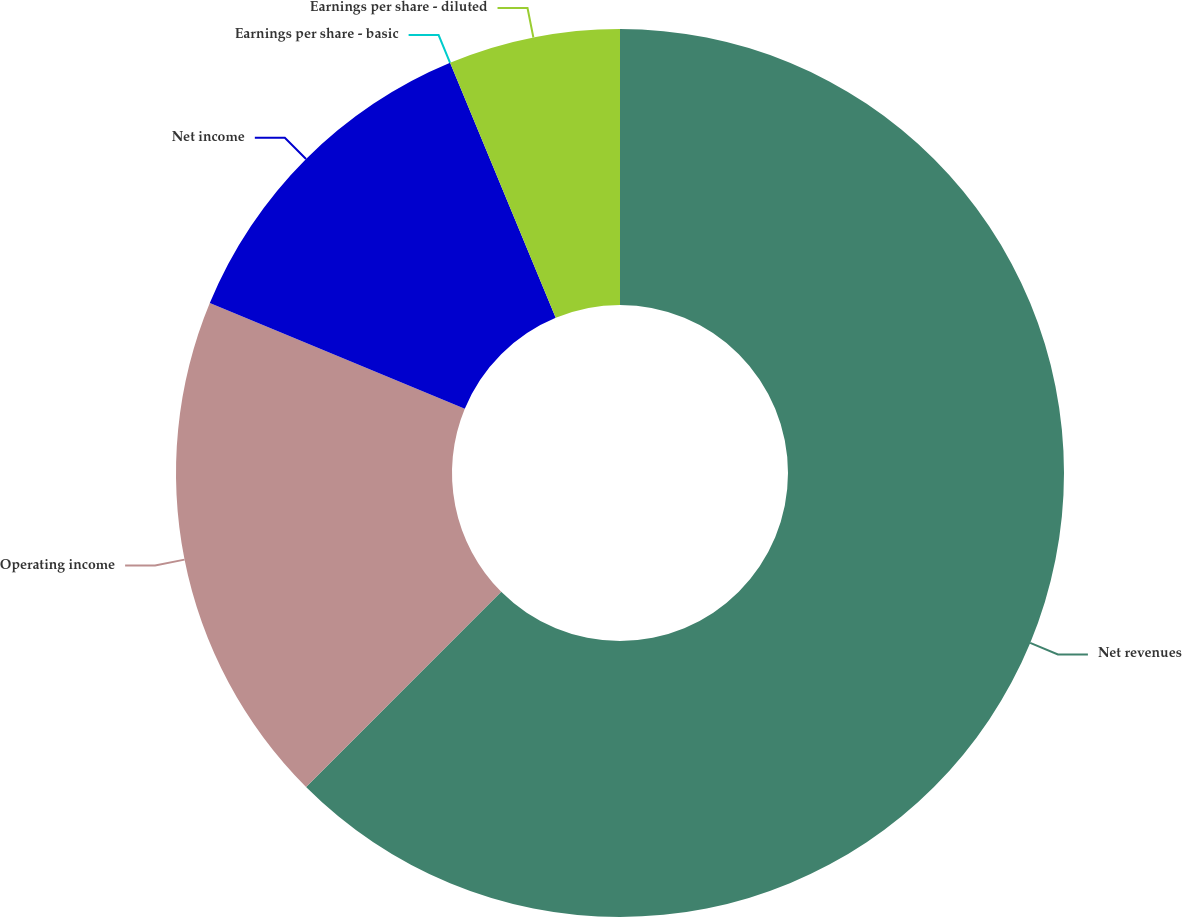Convert chart. <chart><loc_0><loc_0><loc_500><loc_500><pie_chart><fcel>Net revenues<fcel>Operating income<fcel>Net income<fcel>Earnings per share - basic<fcel>Earnings per share - diluted<nl><fcel>62.5%<fcel>18.75%<fcel>12.5%<fcel>0.0%<fcel>6.25%<nl></chart> 